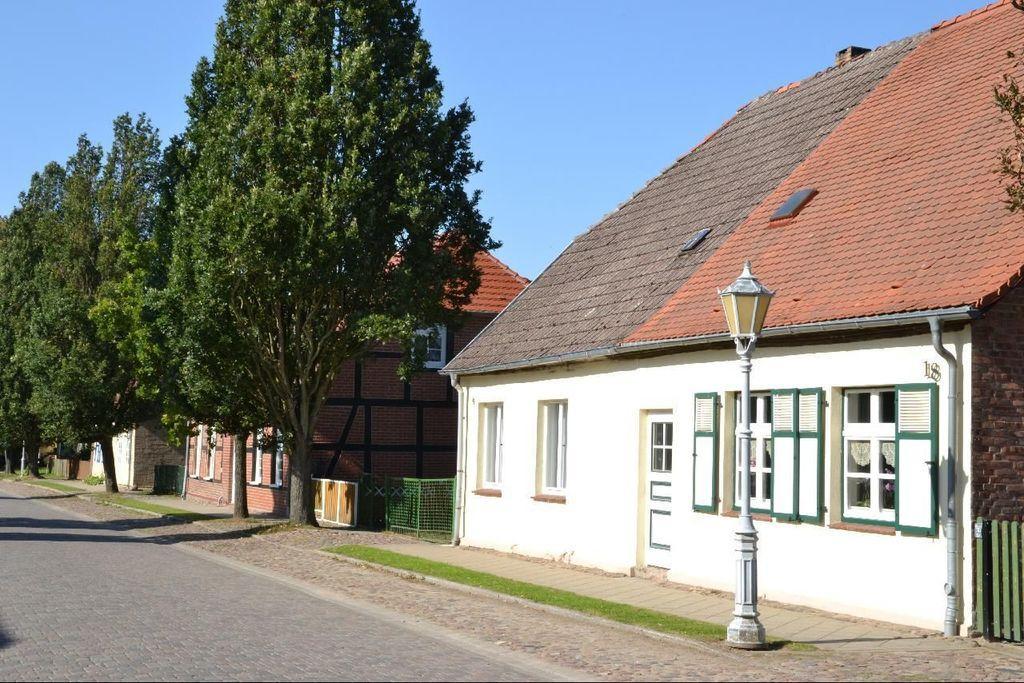How would you summarize this image in a sentence or two? In the picture I can see some houses, few trees, in front of the houses we can see the road. 